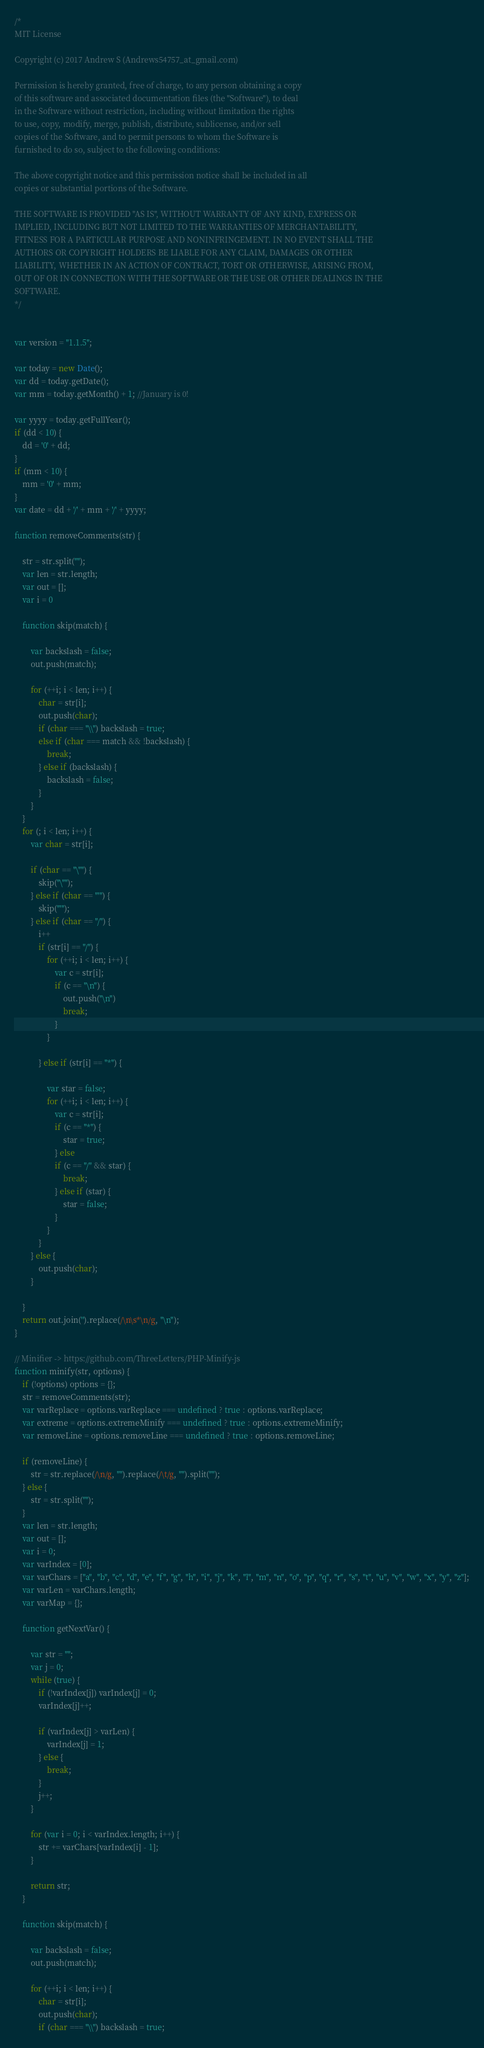Convert code to text. <code><loc_0><loc_0><loc_500><loc_500><_JavaScript_>/*
MIT License

Copyright (c) 2017 Andrew S (Andrews54757_at_gmail.com)

Permission is hereby granted, free of charge, to any person obtaining a copy
of this software and associated documentation files (the "Software"), to deal
in the Software without restriction, including without limitation the rights
to use, copy, modify, merge, publish, distribute, sublicense, and/or sell
copies of the Software, and to permit persons to whom the Software is
furnished to do so, subject to the following conditions:

The above copyright notice and this permission notice shall be included in all
copies or substantial portions of the Software.

THE SOFTWARE IS PROVIDED "AS IS", WITHOUT WARRANTY OF ANY KIND, EXPRESS OR
IMPLIED, INCLUDING BUT NOT LIMITED TO THE WARRANTIES OF MERCHANTABILITY,
FITNESS FOR A PARTICULAR PURPOSE AND NONINFRINGEMENT. IN NO EVENT SHALL THE
AUTHORS OR COPYRIGHT HOLDERS BE LIABLE FOR ANY CLAIM, DAMAGES OR OTHER
LIABILITY, WHETHER IN AN ACTION OF CONTRACT, TORT OR OTHERWISE, ARISING FROM,
OUT OF OR IN CONNECTION WITH THE SOFTWARE OR THE USE OR OTHER DEALINGS IN THE
SOFTWARE.
*/


var version = "1.1.5";

var today = new Date();
var dd = today.getDate();
var mm = today.getMonth() + 1; //January is 0!

var yyyy = today.getFullYear();
if (dd < 10) {
    dd = '0' + dd;
}
if (mm < 10) {
    mm = '0' + mm;
}
var date = dd + '/' + mm + '/' + yyyy;

function removeComments(str) {

    str = str.split("");
    var len = str.length;
    var out = [];
    var i = 0

    function skip(match) {

        var backslash = false;
        out.push(match);

        for (++i; i < len; i++) {
            char = str[i];
            out.push(char);
            if (char === "\\") backslash = true;
            else if (char === match && !backslash) {
                break;
            } else if (backslash) {
                backslash = false;
            }
        }
    }
    for (; i < len; i++) {
        var char = str[i];

        if (char == "\"") {
            skip("\"");
        } else if (char == "'") {
            skip("'");
        } else if (char == "/") {
            i++
            if (str[i] == "/") {
                for (++i; i < len; i++) {
                    var c = str[i];
                    if (c == "\n") {
                        out.push("\n")
                        break;
                    }
                }

            } else if (str[i] == "*") {

                var star = false;
                for (++i; i < len; i++) {
                    var c = str[i];
                    if (c == "*") {
                        star = true;
                    } else
                    if (c == "/" && star) {
                        break;
                    } else if (star) {
                        star = false;
                    }
                }
            }
        } else {
            out.push(char);
        }

    }
    return out.join('').replace(/\n\s*\n/g, "\n");
}

// Minifier -> https://github.com/ThreeLetters/PHP-Minify-js
function minify(str, options) {
    if (!options) options = {};
    str = removeComments(str);
    var varReplace = options.varReplace === undefined ? true : options.varReplace;
    var extreme = options.extremeMinify === undefined ? true : options.extremeMinify;
    var removeLine = options.removeLine === undefined ? true : options.removeLine;

    if (removeLine) {
        str = str.replace(/\n/g, "").replace(/\t/g, "").split("");
    } else {
        str = str.split("");
    }
    var len = str.length;
    var out = [];
    var i = 0;
    var varIndex = [0];
    var varChars = ["a", "b", "c", "d", "e", "f", "g", "h", "i", "j", "k", "l", "m", "n", "o", "p", "q", "r", "s", "t", "u", "v", "w", "x", "y", "z"];
    var varLen = varChars.length;
    var varMap = {};

    function getNextVar() {

        var str = "";
        var j = 0;
        while (true) {
            if (!varIndex[j]) varIndex[j] = 0;
            varIndex[j]++;

            if (varIndex[j] > varLen) {
                varIndex[j] = 1;
            } else {
                break;
            }
            j++;
        }

        for (var i = 0; i < varIndex.length; i++) {
            str += varChars[varIndex[i] - 1];
        }

        return str;
    }

    function skip(match) {

        var backslash = false;
        out.push(match);

        for (++i; i < len; i++) {
            char = str[i];
            out.push(char);
            if (char === "\\") backslash = true;</code> 